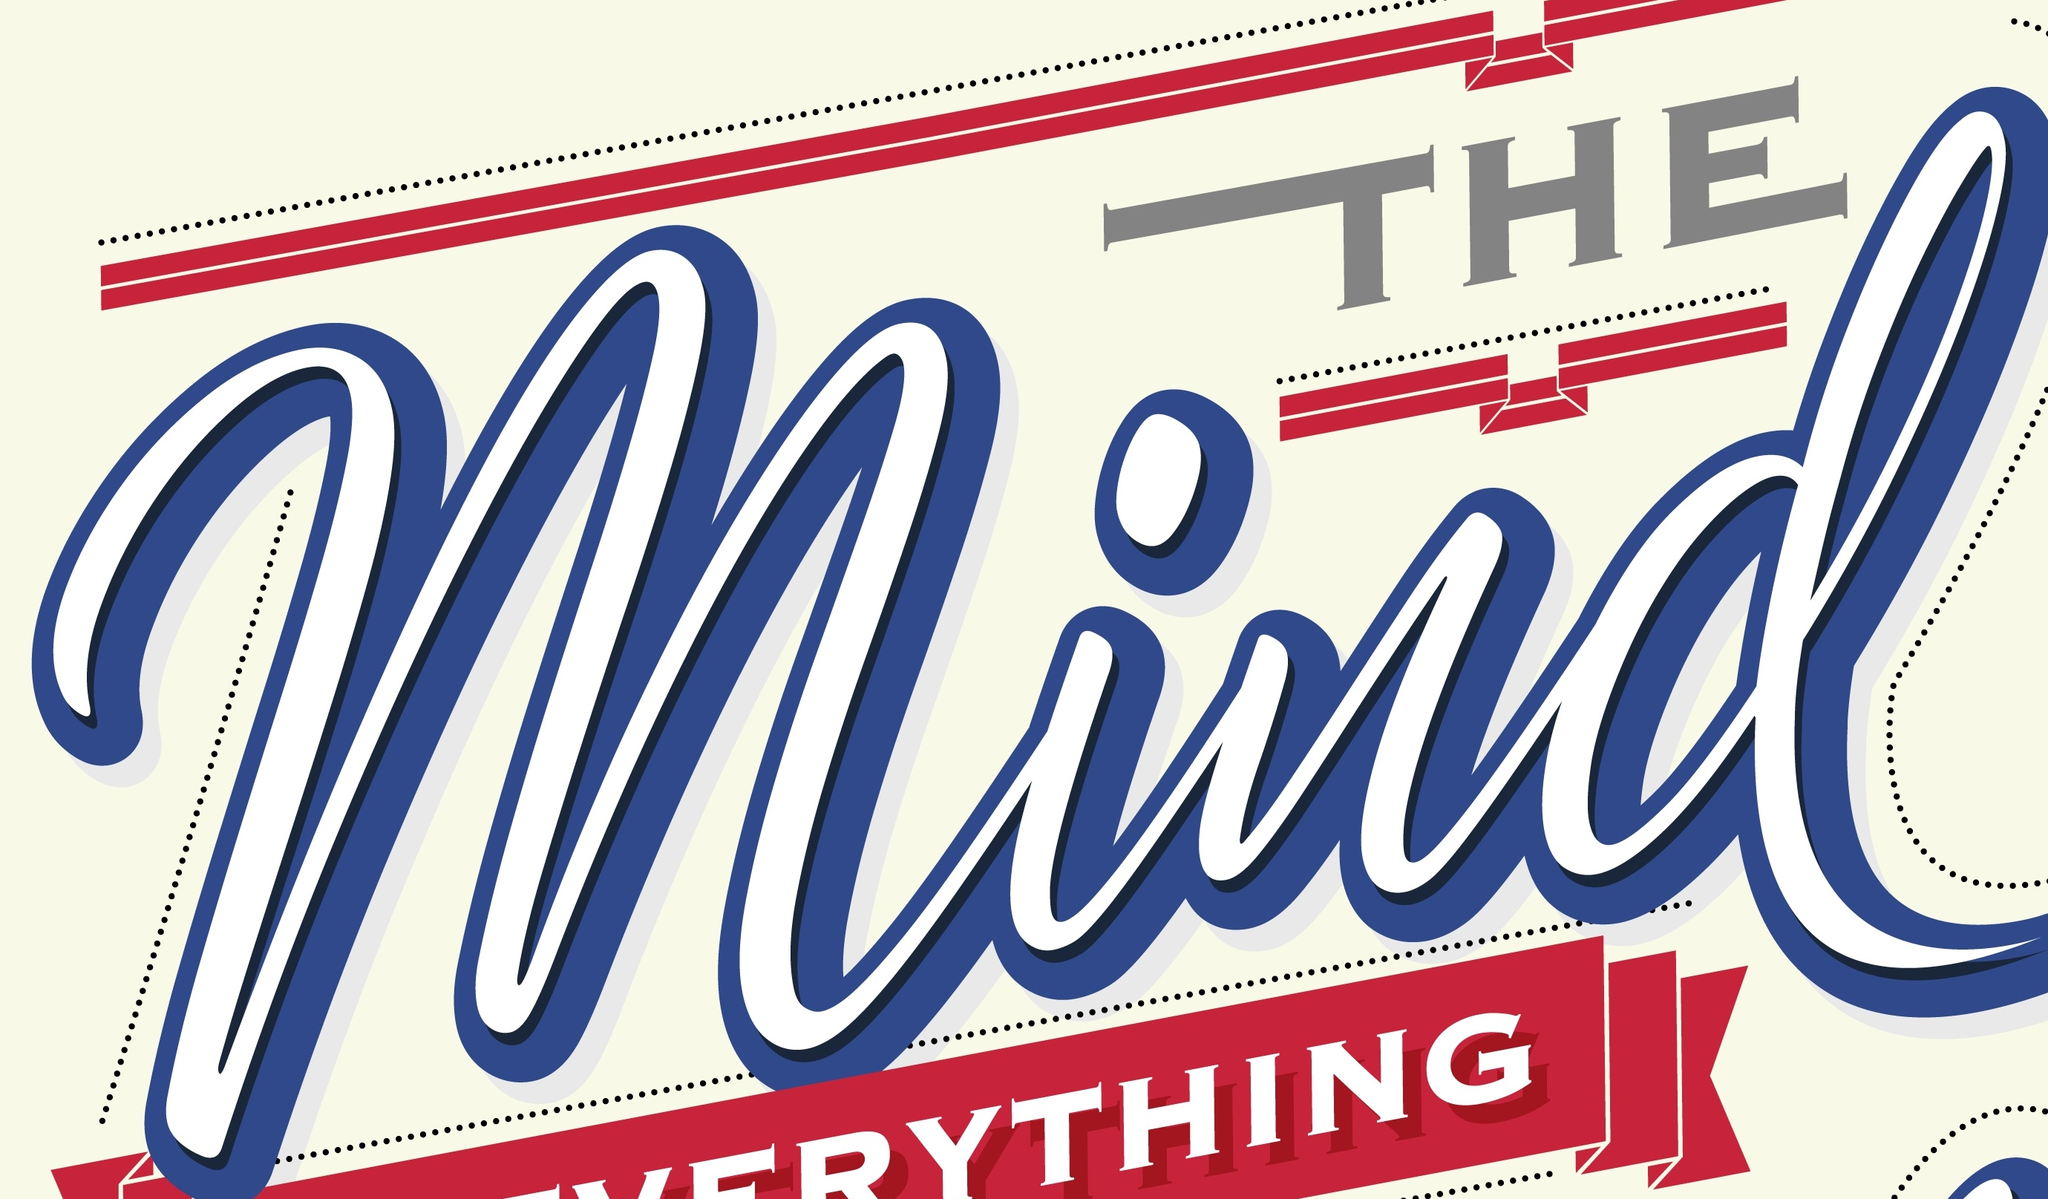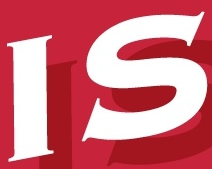Identify the words shown in these images in order, separated by a semicolon. Mind; IS 